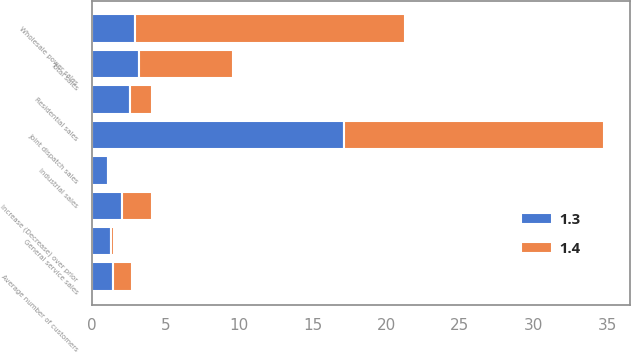Convert chart. <chart><loc_0><loc_0><loc_500><loc_500><stacked_bar_chart><ecel><fcel>Increase (Decrease) over prior<fcel>Residential sales<fcel>General service sales<fcel>Industrial sales<fcel>Wholesale power sales<fcel>Joint dispatch sales<fcel>Total sales<fcel>Average number of customers<nl><fcel>1.3<fcel>2.05<fcel>2.6<fcel>1.3<fcel>1.1<fcel>2.9<fcel>17.1<fcel>3.2<fcel>1.4<nl><fcel>1.4<fcel>2.05<fcel>1.5<fcel>0.2<fcel>0.1<fcel>18.4<fcel>17.7<fcel>6.4<fcel>1.3<nl></chart> 